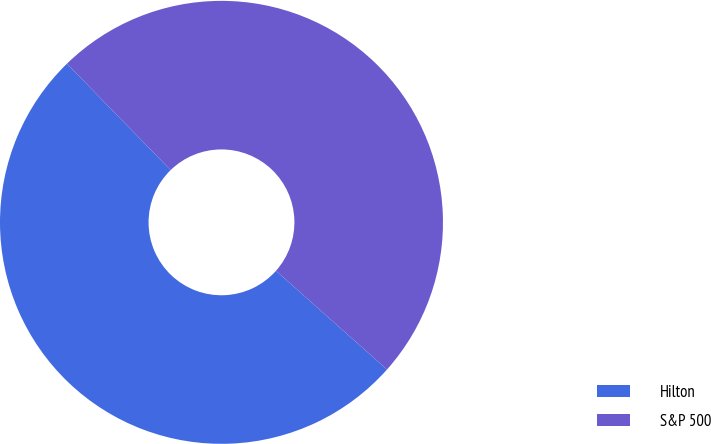<chart> <loc_0><loc_0><loc_500><loc_500><pie_chart><fcel>Hilton<fcel>S&P 500<nl><fcel>51.14%<fcel>48.86%<nl></chart> 